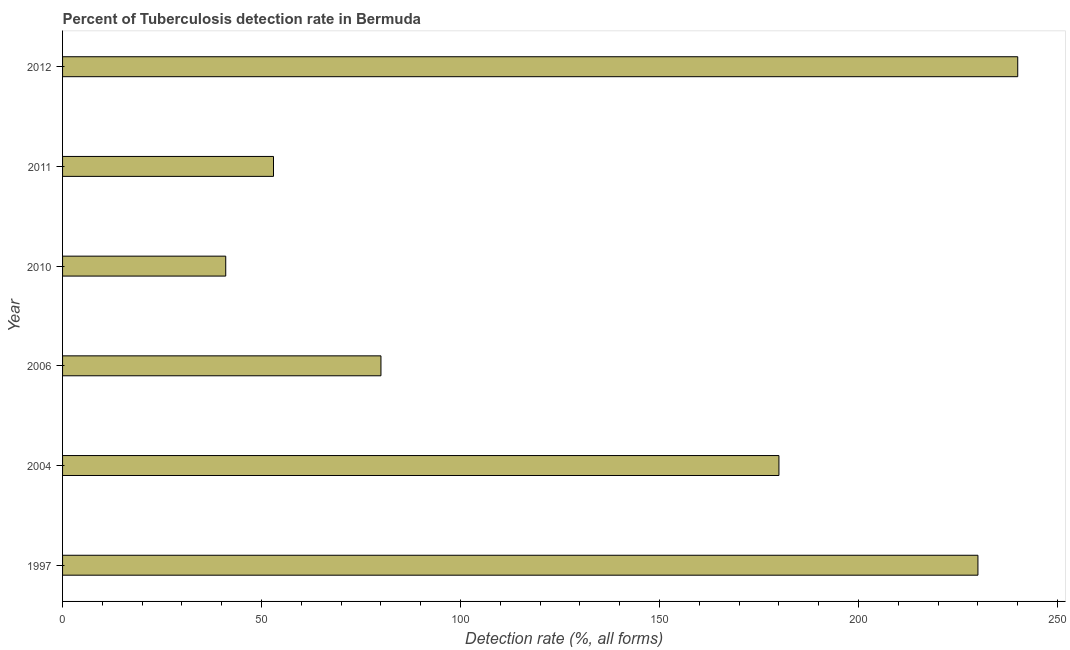What is the title of the graph?
Keep it short and to the point. Percent of Tuberculosis detection rate in Bermuda. What is the label or title of the X-axis?
Your response must be concise. Detection rate (%, all forms). What is the label or title of the Y-axis?
Ensure brevity in your answer.  Year. What is the detection rate of tuberculosis in 1997?
Your response must be concise. 230. Across all years, what is the maximum detection rate of tuberculosis?
Your response must be concise. 240. Across all years, what is the minimum detection rate of tuberculosis?
Offer a terse response. 41. In which year was the detection rate of tuberculosis minimum?
Your response must be concise. 2010. What is the sum of the detection rate of tuberculosis?
Your response must be concise. 824. What is the difference between the detection rate of tuberculosis in 2004 and 2011?
Provide a succinct answer. 127. What is the average detection rate of tuberculosis per year?
Offer a terse response. 137. What is the median detection rate of tuberculosis?
Offer a very short reply. 130. What is the ratio of the detection rate of tuberculosis in 2011 to that in 2012?
Offer a terse response. 0.22. Is the detection rate of tuberculosis in 2004 less than that in 2011?
Your response must be concise. No. What is the difference between the highest and the second highest detection rate of tuberculosis?
Offer a very short reply. 10. Is the sum of the detection rate of tuberculosis in 2004 and 2010 greater than the maximum detection rate of tuberculosis across all years?
Ensure brevity in your answer.  No. What is the difference between the highest and the lowest detection rate of tuberculosis?
Give a very brief answer. 199. How many years are there in the graph?
Your answer should be very brief. 6. Are the values on the major ticks of X-axis written in scientific E-notation?
Your response must be concise. No. What is the Detection rate (%, all forms) in 1997?
Your response must be concise. 230. What is the Detection rate (%, all forms) in 2004?
Provide a succinct answer. 180. What is the Detection rate (%, all forms) in 2010?
Make the answer very short. 41. What is the Detection rate (%, all forms) of 2012?
Your response must be concise. 240. What is the difference between the Detection rate (%, all forms) in 1997 and 2004?
Ensure brevity in your answer.  50. What is the difference between the Detection rate (%, all forms) in 1997 and 2006?
Provide a succinct answer. 150. What is the difference between the Detection rate (%, all forms) in 1997 and 2010?
Provide a succinct answer. 189. What is the difference between the Detection rate (%, all forms) in 1997 and 2011?
Provide a succinct answer. 177. What is the difference between the Detection rate (%, all forms) in 1997 and 2012?
Your answer should be very brief. -10. What is the difference between the Detection rate (%, all forms) in 2004 and 2010?
Offer a terse response. 139. What is the difference between the Detection rate (%, all forms) in 2004 and 2011?
Provide a short and direct response. 127. What is the difference between the Detection rate (%, all forms) in 2004 and 2012?
Your response must be concise. -60. What is the difference between the Detection rate (%, all forms) in 2006 and 2012?
Offer a terse response. -160. What is the difference between the Detection rate (%, all forms) in 2010 and 2012?
Offer a very short reply. -199. What is the difference between the Detection rate (%, all forms) in 2011 and 2012?
Your answer should be compact. -187. What is the ratio of the Detection rate (%, all forms) in 1997 to that in 2004?
Give a very brief answer. 1.28. What is the ratio of the Detection rate (%, all forms) in 1997 to that in 2006?
Provide a short and direct response. 2.88. What is the ratio of the Detection rate (%, all forms) in 1997 to that in 2010?
Keep it short and to the point. 5.61. What is the ratio of the Detection rate (%, all forms) in 1997 to that in 2011?
Your answer should be compact. 4.34. What is the ratio of the Detection rate (%, all forms) in 1997 to that in 2012?
Your answer should be very brief. 0.96. What is the ratio of the Detection rate (%, all forms) in 2004 to that in 2006?
Your response must be concise. 2.25. What is the ratio of the Detection rate (%, all forms) in 2004 to that in 2010?
Your response must be concise. 4.39. What is the ratio of the Detection rate (%, all forms) in 2004 to that in 2011?
Provide a short and direct response. 3.4. What is the ratio of the Detection rate (%, all forms) in 2004 to that in 2012?
Offer a very short reply. 0.75. What is the ratio of the Detection rate (%, all forms) in 2006 to that in 2010?
Offer a terse response. 1.95. What is the ratio of the Detection rate (%, all forms) in 2006 to that in 2011?
Keep it short and to the point. 1.51. What is the ratio of the Detection rate (%, all forms) in 2006 to that in 2012?
Give a very brief answer. 0.33. What is the ratio of the Detection rate (%, all forms) in 2010 to that in 2011?
Give a very brief answer. 0.77. What is the ratio of the Detection rate (%, all forms) in 2010 to that in 2012?
Offer a very short reply. 0.17. What is the ratio of the Detection rate (%, all forms) in 2011 to that in 2012?
Offer a terse response. 0.22. 